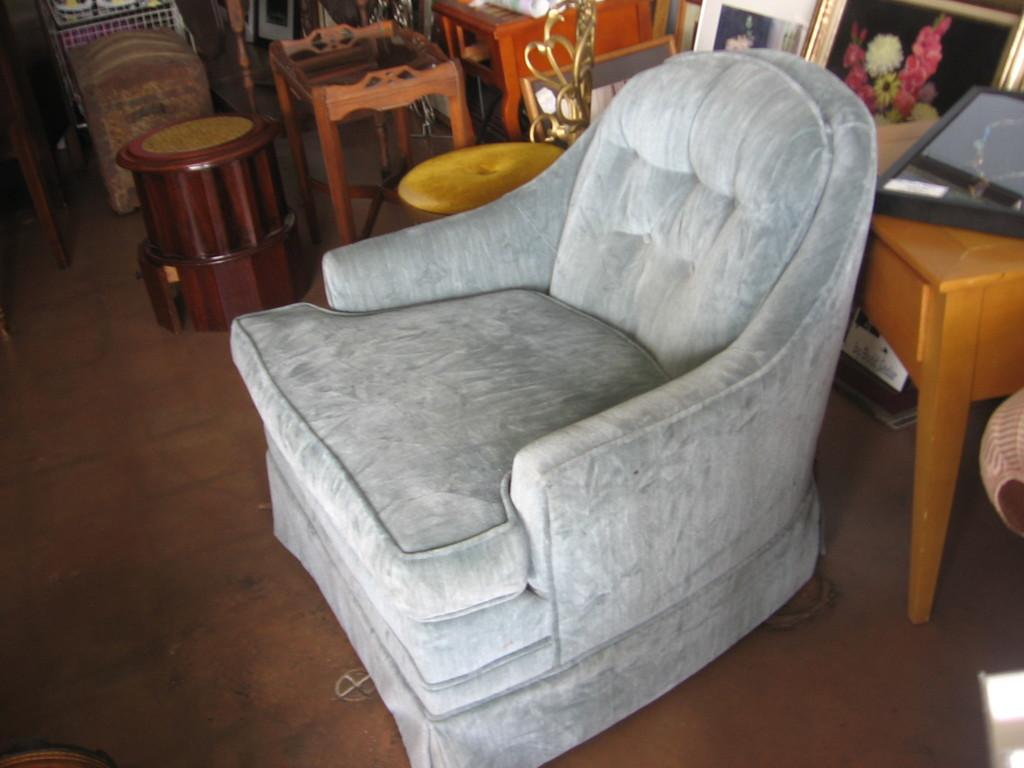What type of furniture is present in the image? There is a sofa and stools in the image. What can be seen hanging on the walls in the image? There are photo frames in the image. What type of music can be heard playing in the background of the image? There is no indication of music or any sound in the image, as it is a still image. Can you see a nest in the image? There is no nest present in the image. 